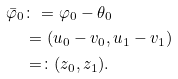<formula> <loc_0><loc_0><loc_500><loc_500>\bar { \varphi } _ { 0 } & \colon = \varphi _ { 0 } - \theta _ { 0 } \\ & = ( u _ { 0 } - v _ { 0 } , u _ { 1 } - v _ { 1 } ) \\ & = \colon ( z _ { 0 } , z _ { 1 } ) .</formula> 